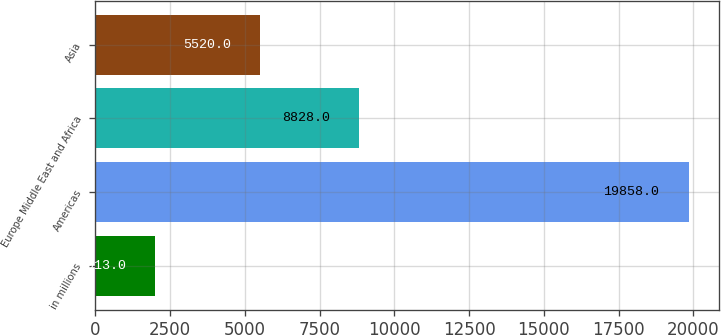<chart> <loc_0><loc_0><loc_500><loc_500><bar_chart><fcel>in millions<fcel>Americas<fcel>Europe Middle East and Africa<fcel>Asia<nl><fcel>2013<fcel>19858<fcel>8828<fcel>5520<nl></chart> 